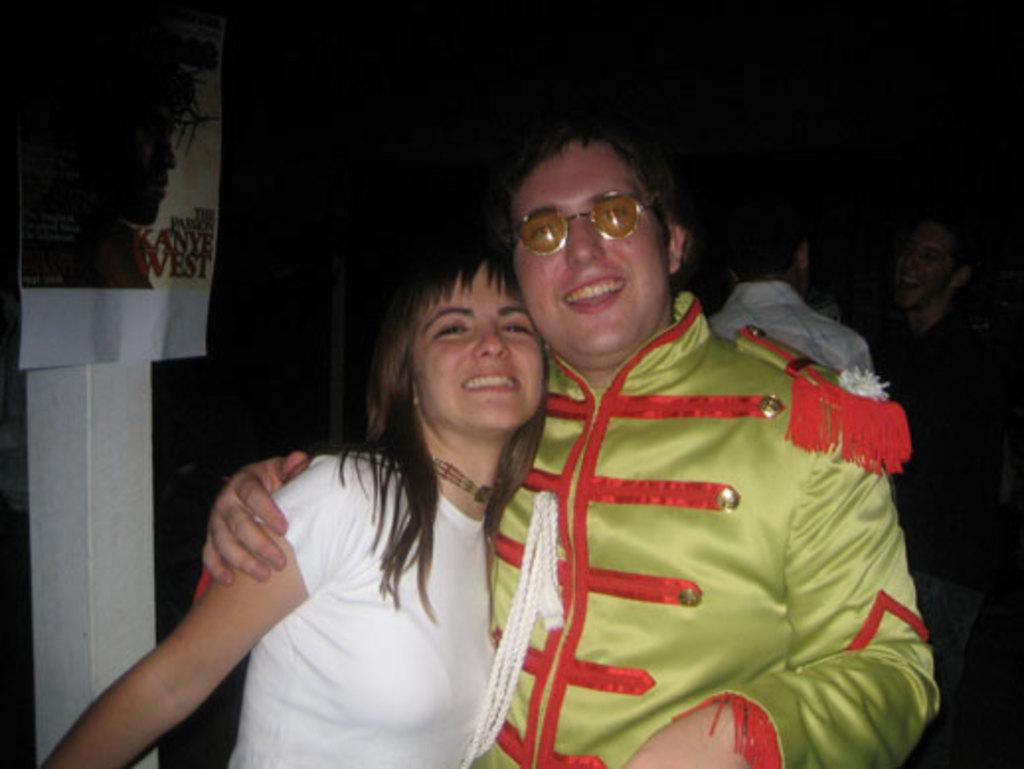How many people are in the image? There is a group of people in the image. Can you describe the man in the middle of the image? The man in the middle of the image is wearing spectacles. What is located beside the man? There is a poster beside the man. What type of book is the snake holding in the image? There is no snake or book present in the image. 